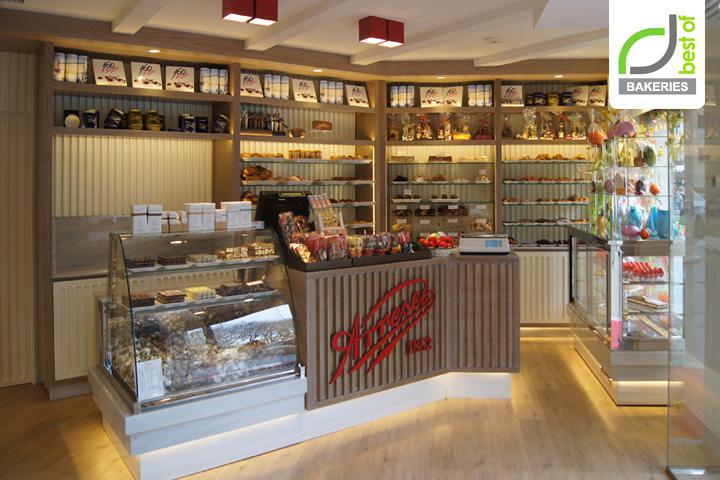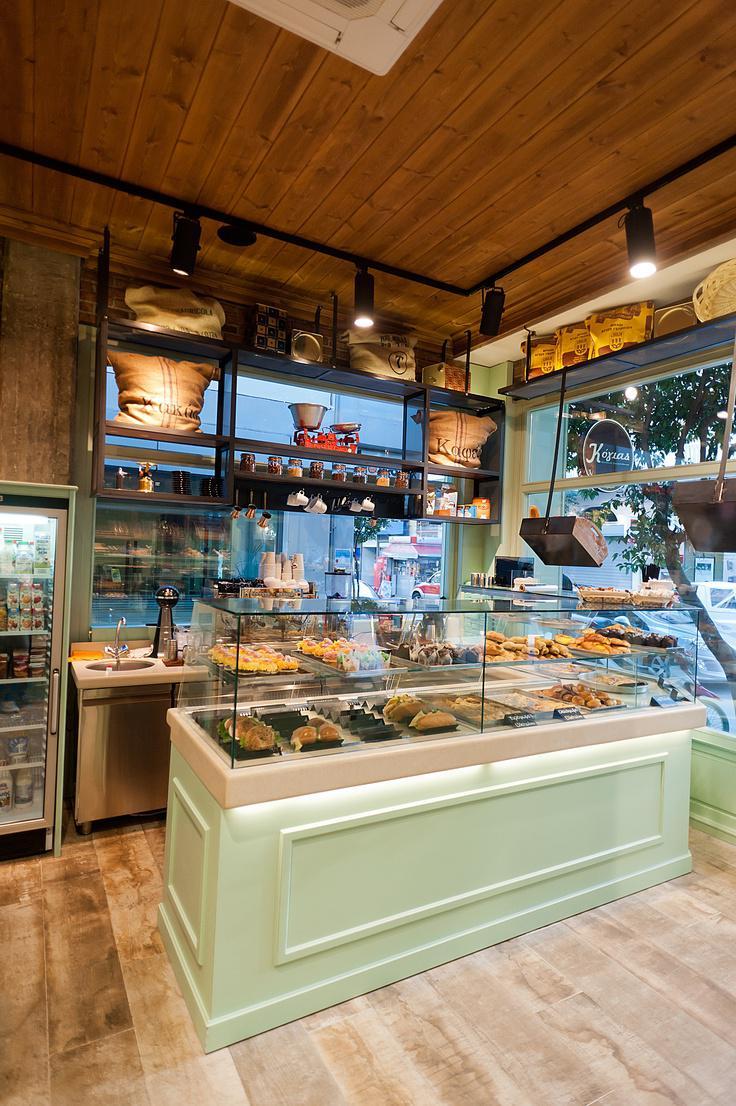The first image is the image on the left, the second image is the image on the right. Examine the images to the left and right. Is the description "There is at least one square table with chairs inside a bakery." accurate? Answer yes or no. No. The first image is the image on the left, the second image is the image on the right. For the images shown, is this caption "Right image shows a bakery with pale green display cases and black track lighting suspended from a wood plank ceiling." true? Answer yes or no. Yes. 